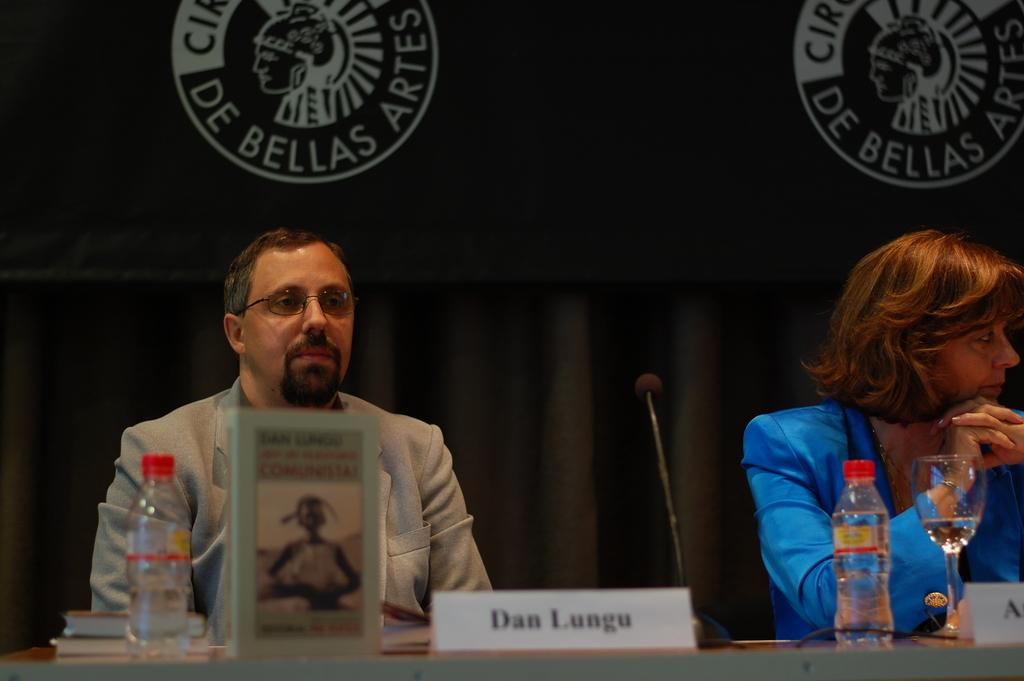How many people are sitting in the image? There are two people sitting in the image. What is in front of the people? There is a table in front of the people. What items can be seen on the table? There are books, bottles, a microphone (mic), and a glass on the table. What is visible in the background of the image? There is a curtain with logos in the background. What letter is the person in the image trying to write on the table? There is no indication in the image that anyone is trying to write a letter on the table. 